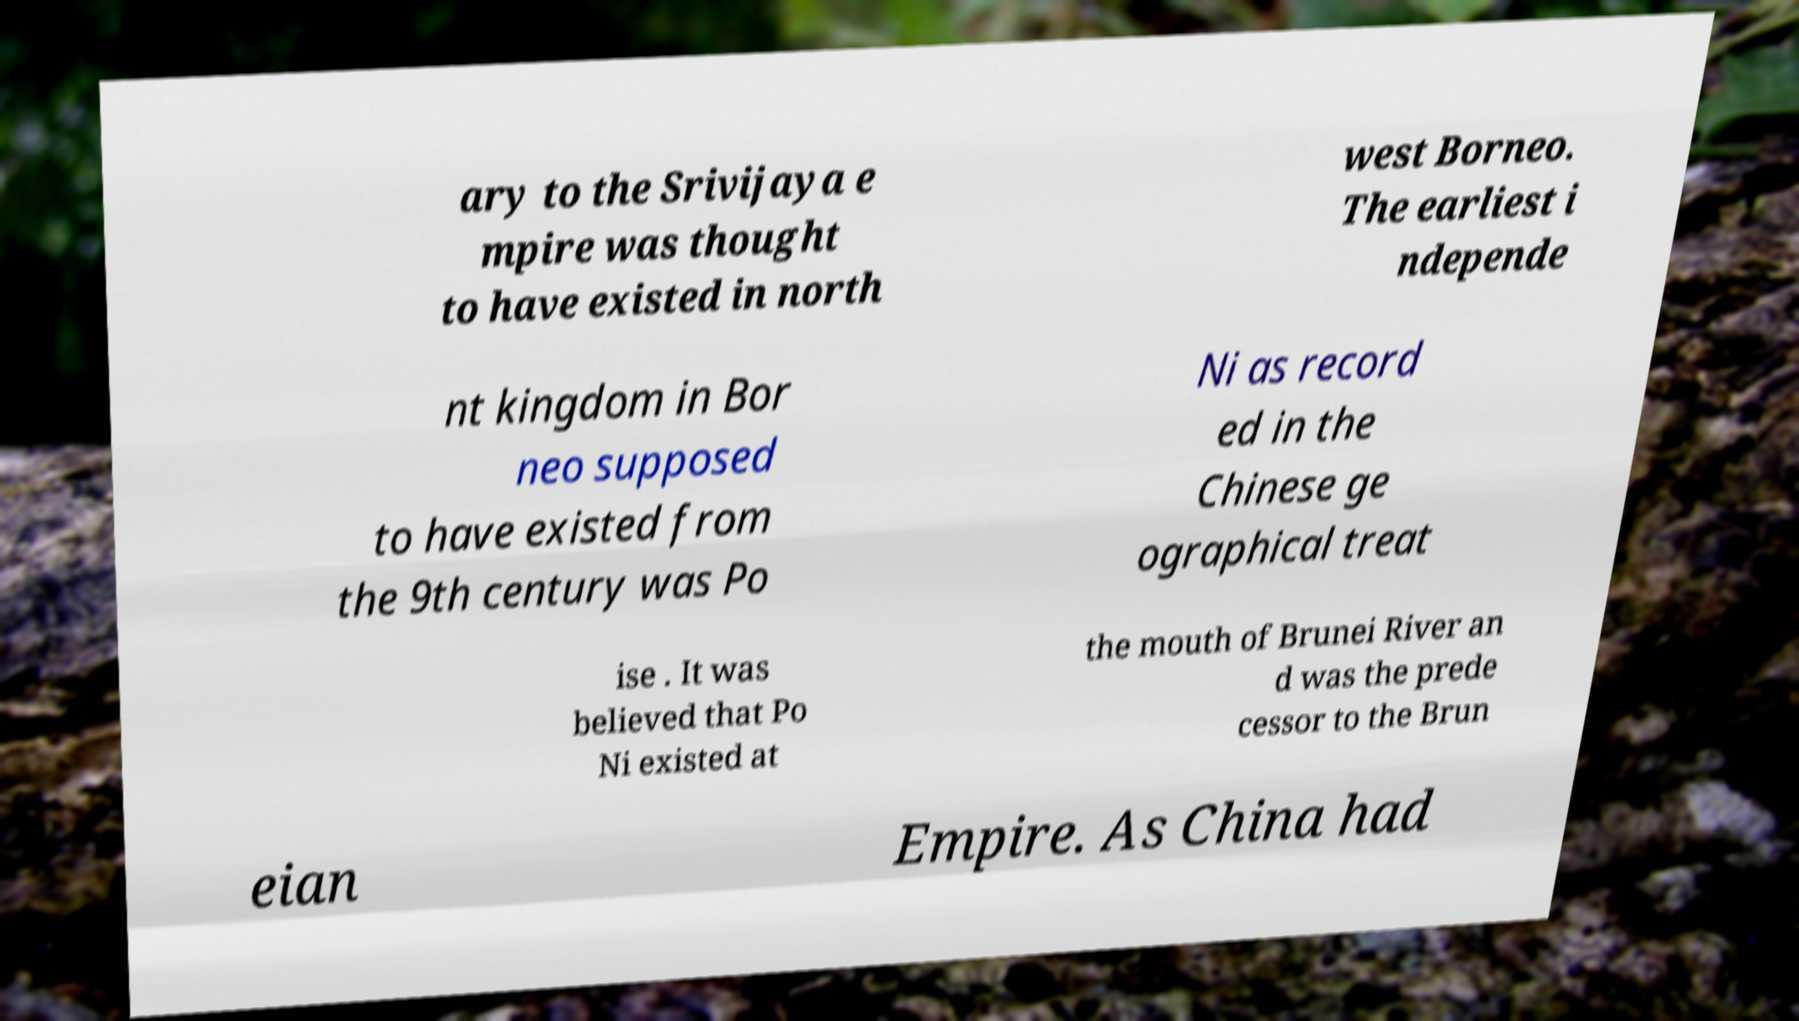What messages or text are displayed in this image? I need them in a readable, typed format. ary to the Srivijaya e mpire was thought to have existed in north west Borneo. The earliest i ndepende nt kingdom in Bor neo supposed to have existed from the 9th century was Po Ni as record ed in the Chinese ge ographical treat ise . It was believed that Po Ni existed at the mouth of Brunei River an d was the prede cessor to the Brun eian Empire. As China had 